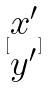Convert formula to latex. <formula><loc_0><loc_0><loc_500><loc_500>[ \begin{matrix} x ^ { \prime } \\ y ^ { \prime } \end{matrix} ]</formula> 